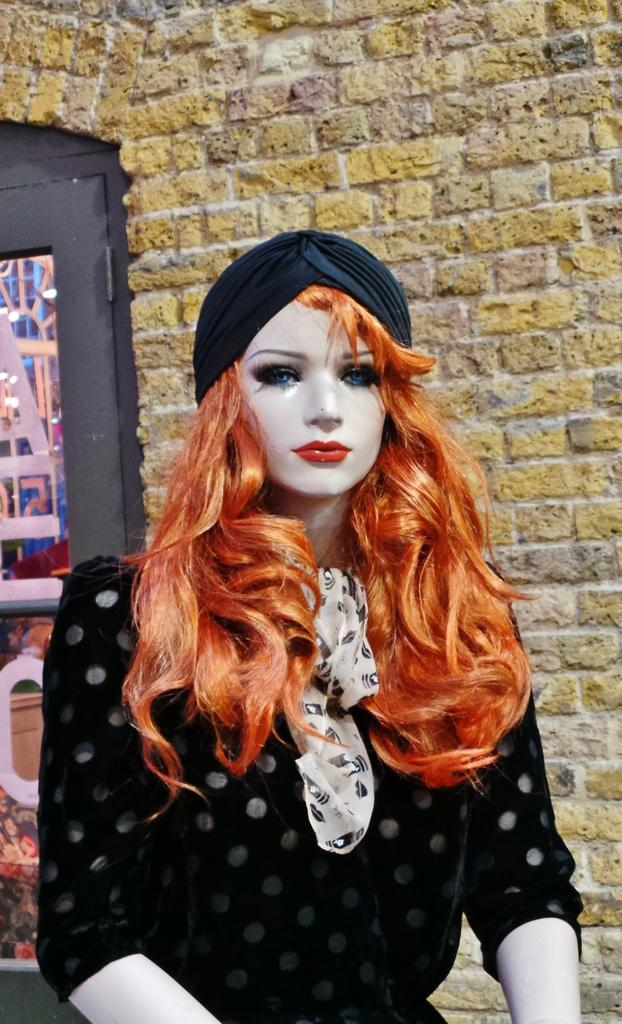What is the main subject of the image? There is a doll in the image. What is the doll wearing? The doll is wearing a black dress. What can be seen on the left side of the image? There is a glass window on the left side of the image. What is visible in the background of the image? There is a brick wall in the background of the image. What type of flame can be seen flickering near the doll in the image? There is no flame present in the image; it features a doll wearing a black dress with a glass window on the left side and a brick wall in the background. 